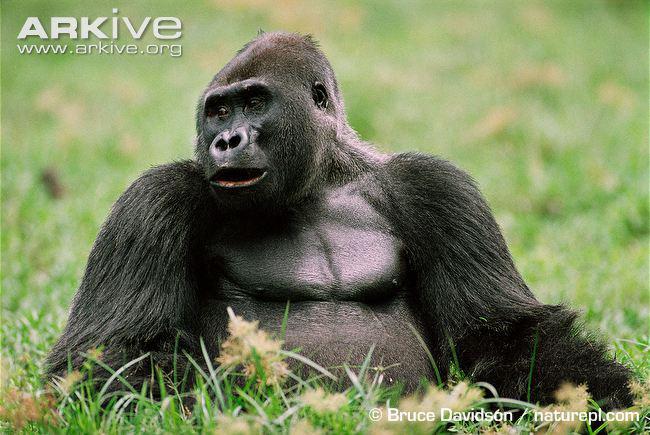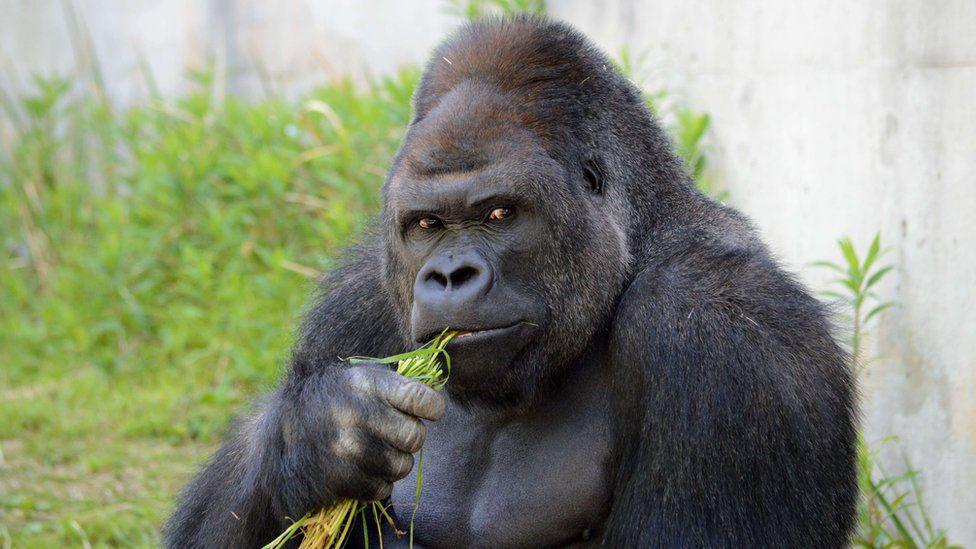The first image is the image on the left, the second image is the image on the right. Analyze the images presented: Is the assertion "there's at least one gorilla sitting" valid? Answer yes or no. Yes. 